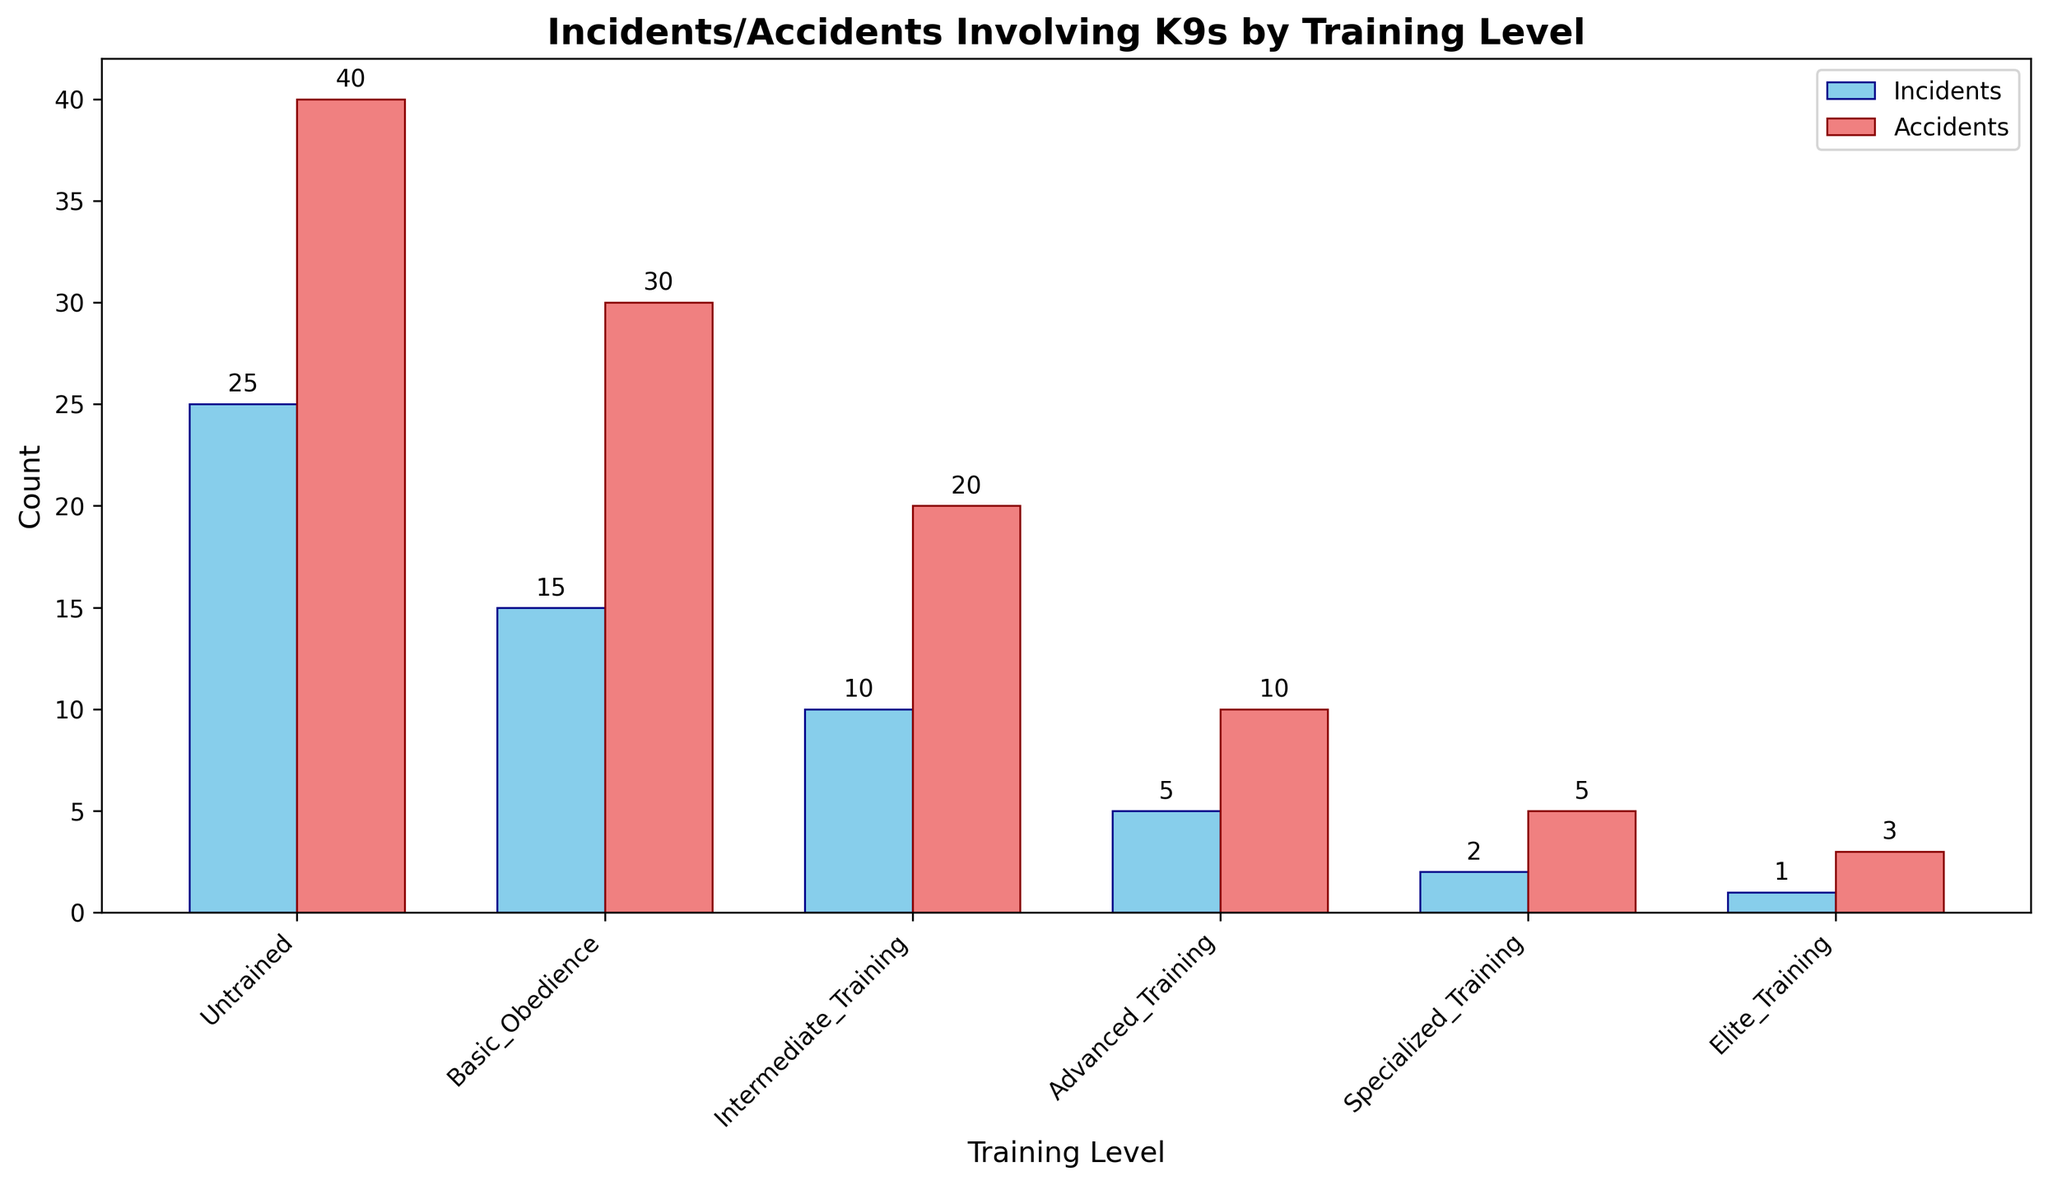What is the training level with the highest number of incidents? Looking at the bars representing incidents, the 'Untrained' category visibly has the tallest bar for incidents.
Answer: Untrained What is the difference in the number of accidents between 'Basic Obedience' and 'Advanced Training' levels? For 'Basic Obedience', the accident count is 30. For 'Advanced Training', the accident count is 10. Subtract the two values: 30 - 10 = 20.
Answer: 20 How many total incidents and accidents are reported for 'Intermediate Training'? The figure shows 10 incidents and 20 accidents for 'Intermediate Training'. Sum these values: 10 + 20 = 30.
Answer: 30 Which training level shows the least incidents? By looking at the heights of the bars representing incidents, 'Elite Training' has the shortest bar with 1 incident.
Answer: Elite Training How does the number of incidents in 'Intermediate Training' compare to the incidents in 'Advanced Training'? The number of incidents in 'Intermediate Training' is 10, while it is 5 in 'Advanced Training'. So, 'Intermediate Training' has more incidents.
Answer: Intermediate Training What is the total number of incidents and accidents involving K9s at the 'Elite Training' level? The figure shows 1 incident and 3 accidents for 'Elite Training'. Adding these together: 1 + 3 = 4.
Answer: 4 What is the average number of accidents across all training levels? Sum all the accident numbers: 40 + 30 + 20 + 10 + 5 + 3 = 108. Then divide by the number of levels, which is 6: 108 / 6 = 18.
Answer: 18 Between 'Basic Obedience' and 'Specialized Training', which has more incidents and by how much? 'Basic Obedience' has 15 incidents, while 'Specialized Training' has 2 incidents. The difference is: 15 - 2 = 13.
Answer: Basic Obedience by 13 What color represents the bars for total incidents? The bars representing incidents are colored in sky blue.
Answer: Sky blue Is there any training level where the number of incidents is equal to the number of accidents? From the figure, no training level has equal incidents and accidents; all counts differ.
Answer: No 